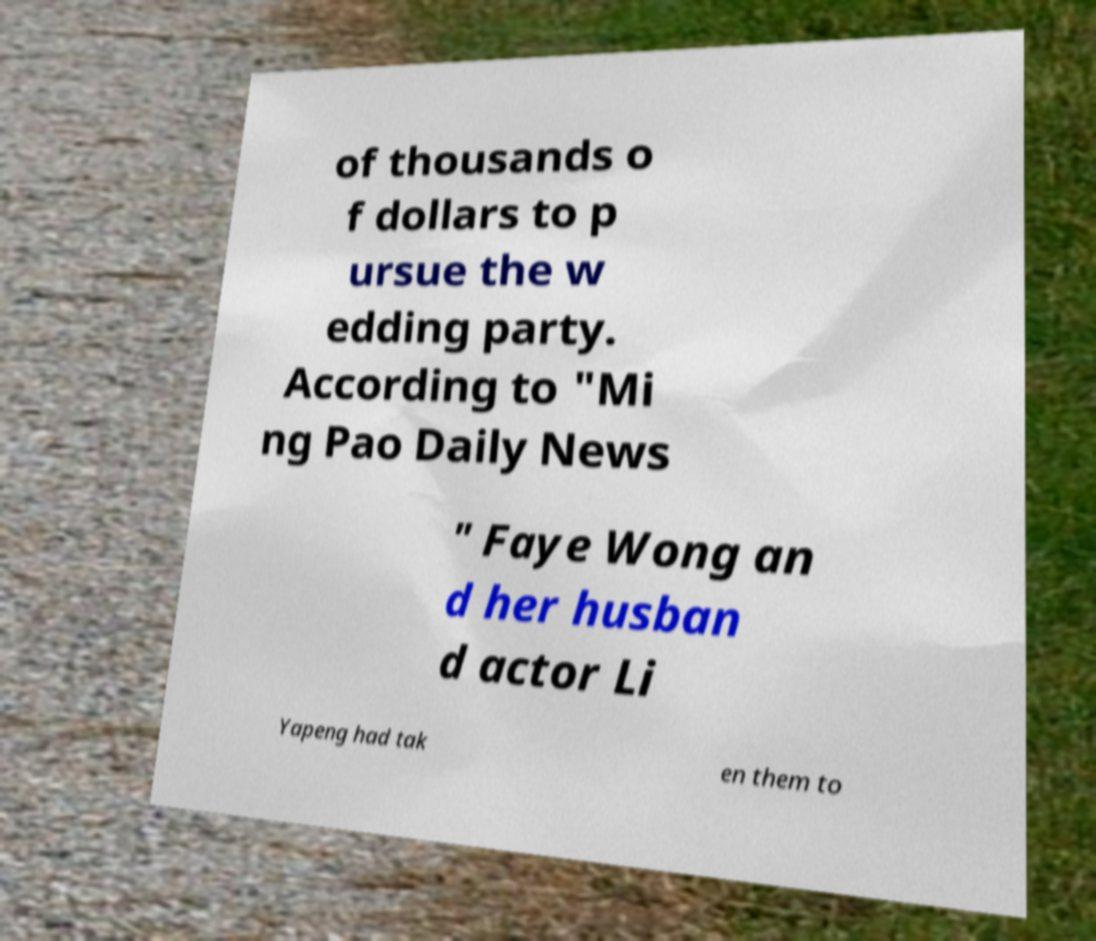Please identify and transcribe the text found in this image. of thousands o f dollars to p ursue the w edding party. According to "Mi ng Pao Daily News " Faye Wong an d her husban d actor Li Yapeng had tak en them to 